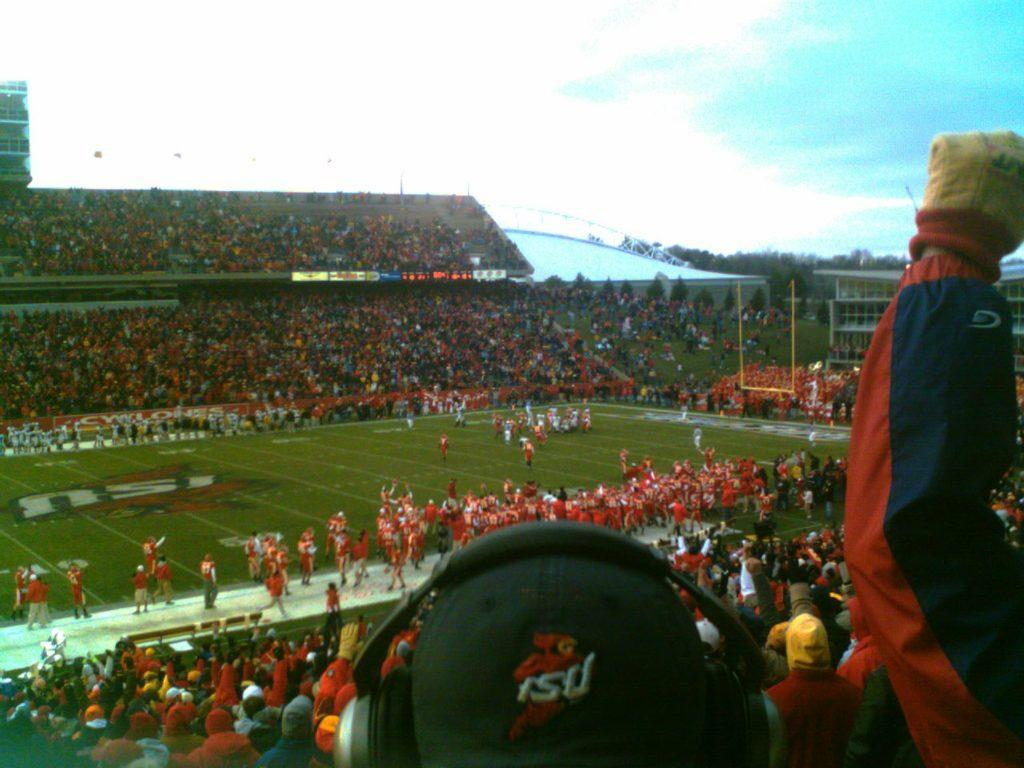What type of structure is shown in the image? There is a stadium in the image. Can you describe the people in the image? There are groups of people in the image. What else can be seen in the image besides the stadium and people? There are boards and trees in the image. What is visible in the background of the image? The sky is visible in the background of the image. What type of engine is used to power the stadium in the image? There is no engine present in the image, as the stadium is a stationary structure. 